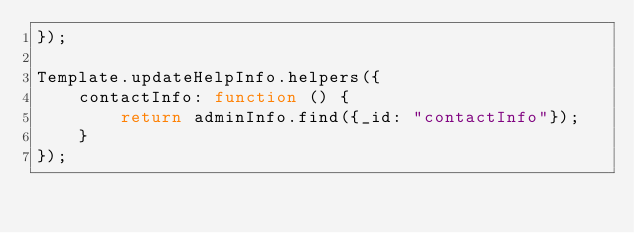Convert code to text. <code><loc_0><loc_0><loc_500><loc_500><_JavaScript_>});

Template.updateHelpInfo.helpers({
    contactInfo: function () {
        return adminInfo.find({_id: "contactInfo"});
    }
});
</code> 